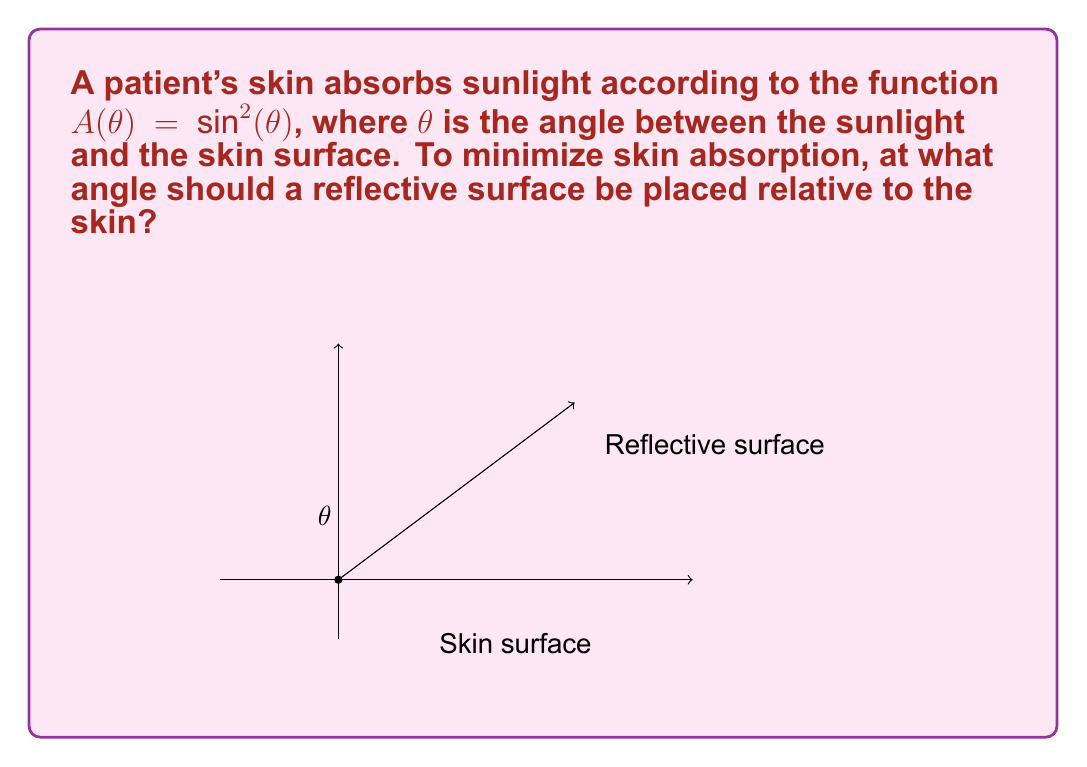What is the answer to this math problem? To solve this problem, we need to follow these steps:

1) The absorption function is given as $A(\theta) = \sin^2(\theta)$. To minimize absorption, we need to minimize this function.

2) To find the minimum of $A(\theta)$, we need to find where its derivative equals zero:

   $$\frac{d}{d\theta}A(\theta) = \frac{d}{d\theta}\sin^2(\theta) = 2\sin(\theta)\cos(\theta) = \sin(2\theta)$$

3) Setting this equal to zero:

   $$\sin(2\theta) = 0$$

4) The solutions to this equation are:

   $$2\theta = 0, \pi, 2\pi, ...$$

   $$\theta = 0, \frac{\pi}{2}, \pi, ...$$

5) The minimum occurs at $\theta = 0$ (as $\theta = \pi$ would mean the light is parallel to the skin, which is not practical).

6) If $\theta = 0$ between the sunlight and the skin, then the reflective surface should be perpendicular to the skin to reflect the light away.

7) The angle between the reflective surface and the skin should therefore be 90°.
Answer: 90° 